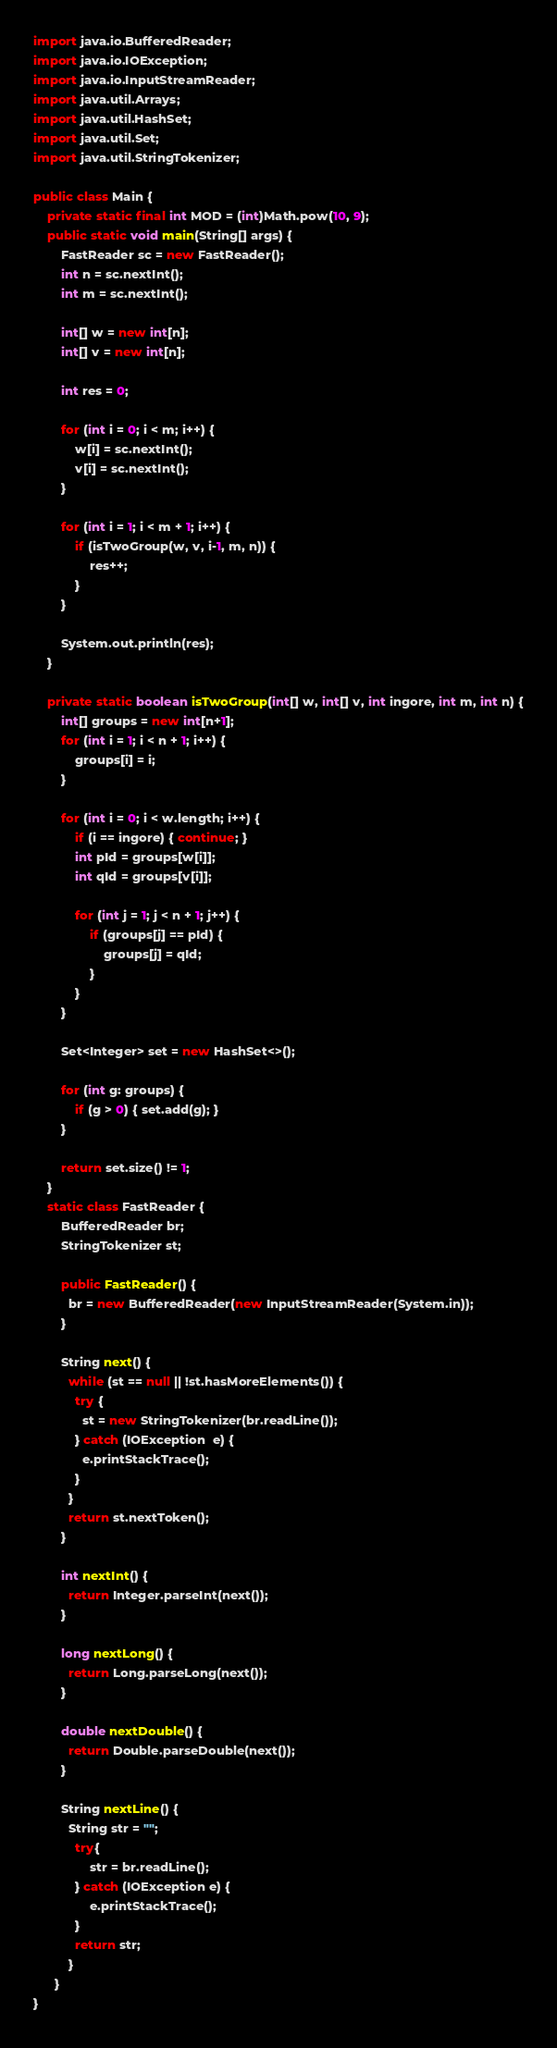Convert code to text. <code><loc_0><loc_0><loc_500><loc_500><_Java_>
import java.io.BufferedReader;
import java.io.IOException;
import java.io.InputStreamReader;
import java.util.Arrays;
import java.util.HashSet;
import java.util.Set;
import java.util.StringTokenizer;

public class Main {
	private static final int MOD = (int)Math.pow(10, 9);
	public static void main(String[] args) {
		FastReader sc = new FastReader();
		int n = sc.nextInt();
		int m = sc.nextInt();
		
		int[] w = new int[n];
		int[] v = new int[n];
		
		int res = 0;
		
		for (int i = 0; i < m; i++) {
			w[i] = sc.nextInt();
			v[i] = sc.nextInt();
		}
		
		for (int i = 1; i < m + 1; i++) {
			if (isTwoGroup(w, v, i-1, m, n)) {
				res++;
			}
		}
		
		System.out.println(res);
	}
	
	private static boolean isTwoGroup(int[] w, int[] v, int ingore, int m, int n) {
		int[] groups = new int[n+1];
		for (int i = 1; i < n + 1; i++) {
			groups[i] = i;
		}
		
		for (int i = 0; i < w.length; i++) {
			if (i == ingore) { continue; }
			int pId = groups[w[i]];
			int qId = groups[v[i]];
			
			for (int j = 1; j < n + 1; j++) {
				if (groups[j] == pId) {
					groups[j] = qId;
				}
			}
		}
		
		Set<Integer> set = new HashSet<>();
		
		for (int g: groups) {
			if (g > 0) { set.add(g); }
		}
		
		return set.size() != 1;
	}
    static class FastReader {
	    BufferedReader br;
	    StringTokenizer st;
	
	    public FastReader() {
	      br = new BufferedReader(new InputStreamReader(System.in));
	    }
	  
	    String next() { 
	      while (st == null || !st.hasMoreElements()) {
	        try {
	          st = new StringTokenizer(br.readLine());
	        } catch (IOException  e) {
	          e.printStackTrace();
	        }
	      }
	      return st.nextToken();
	    }
	
	    int nextInt() {
	      return Integer.parseInt(next());
	    }
	
	    long nextLong() {
	      return Long.parseLong(next());
	    }
	
	    double nextDouble() { 
	      return Double.parseDouble(next());
	    }
	
	    String nextLine() {
	      String str = "";
	        try{
	            str = br.readLine();
	        } catch (IOException e) {
	            e.printStackTrace();
	        }
	        return str;
	      }
	  }
}
</code> 